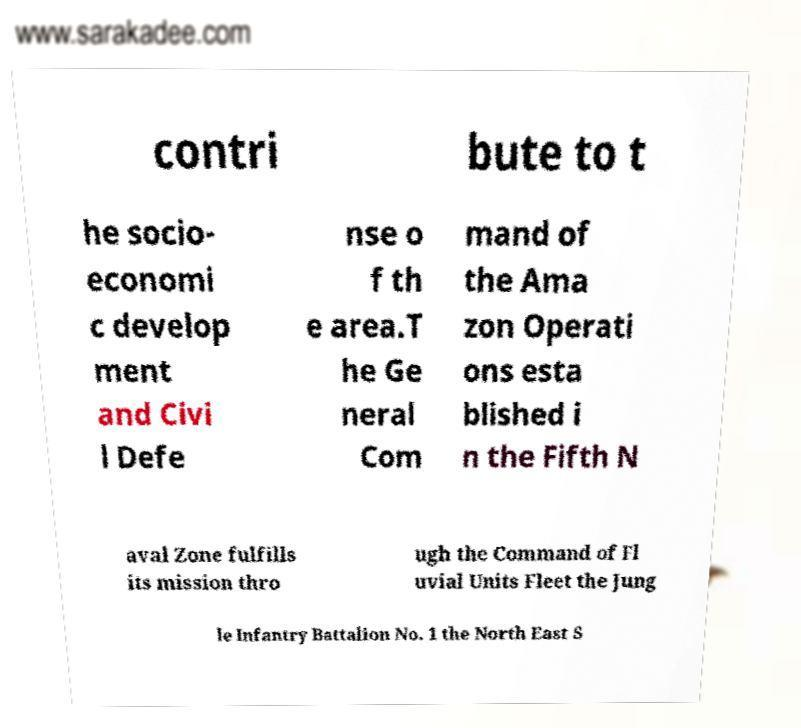Please identify and transcribe the text found in this image. contri bute to t he socio- economi c develop ment and Civi l Defe nse o f th e area.T he Ge neral Com mand of the Ama zon Operati ons esta blished i n the Fifth N aval Zone fulfills its mission thro ugh the Command of Fl uvial Units Fleet the Jung le Infantry Battalion No. 1 the North East S 